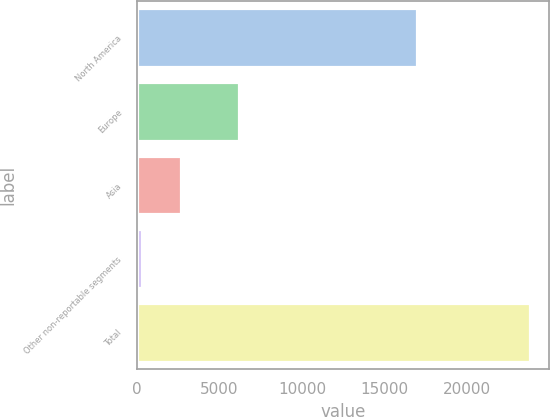Convert chart. <chart><loc_0><loc_0><loc_500><loc_500><bar_chart><fcel>North America<fcel>Europe<fcel>Asia<fcel>Other non-reportable segments<fcel>Total<nl><fcel>16970<fcel>6164<fcel>2678.3<fcel>331<fcel>23804<nl></chart> 